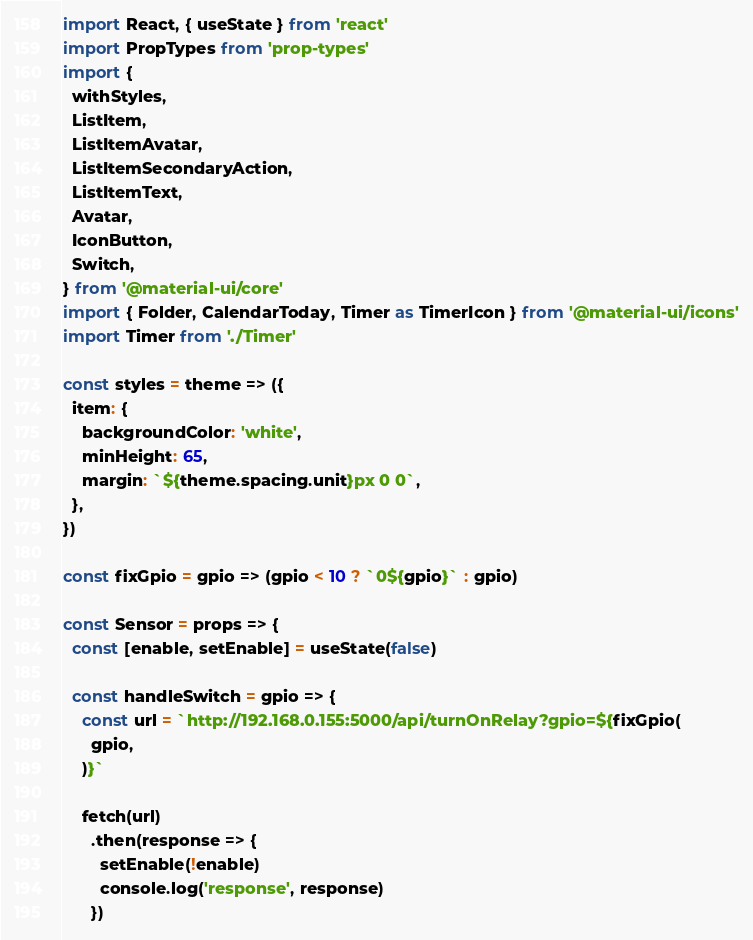Convert code to text. <code><loc_0><loc_0><loc_500><loc_500><_JavaScript_>import React, { useState } from 'react'
import PropTypes from 'prop-types'
import {
  withStyles,
  ListItem,
  ListItemAvatar,
  ListItemSecondaryAction,
  ListItemText,
  Avatar,
  IconButton,
  Switch,
} from '@material-ui/core'
import { Folder, CalendarToday, Timer as TimerIcon } from '@material-ui/icons'
import Timer from './Timer'

const styles = theme => ({
  item: {
    backgroundColor: 'white',
    minHeight: 65,
    margin: `${theme.spacing.unit}px 0 0`,
  },
})

const fixGpio = gpio => (gpio < 10 ? `0${gpio}` : gpio)

const Sensor = props => {
  const [enable, setEnable] = useState(false)

  const handleSwitch = gpio => {
    const url = `http://192.168.0.155:5000/api/turnOnRelay?gpio=${fixGpio(
      gpio,
    )}`

    fetch(url)
      .then(response => {
        setEnable(!enable)
        console.log('response', response)
      })</code> 